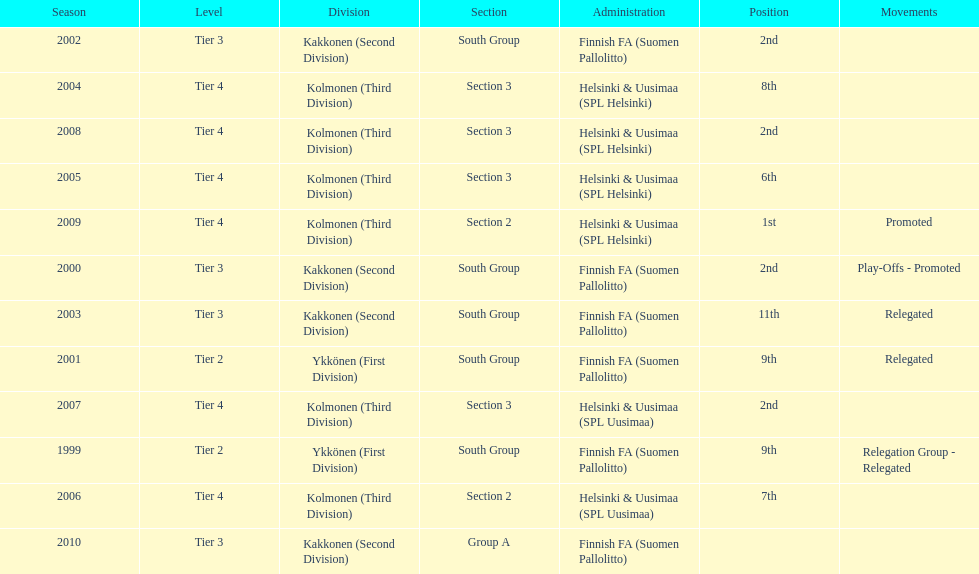When was the last year they placed 2nd? 2008. 